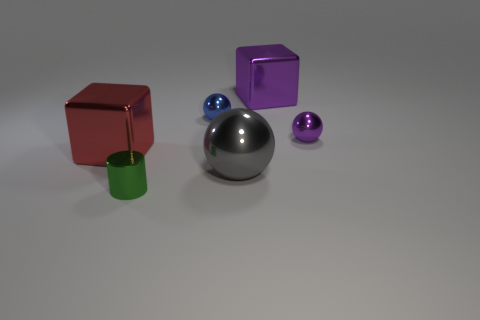There is a tiny cylinder in front of the cube that is right of the large object that is to the left of the small green metal thing; what is its material?
Offer a terse response. Metal. What number of red things are there?
Provide a short and direct response. 1. How many cyan objects are big balls or small balls?
Provide a short and direct response. 0. What number of other objects are the same shape as the large purple object?
Your answer should be compact. 1. There is a cube that is right of the small green metallic thing; does it have the same color as the tiny sphere that is in front of the blue sphere?
Make the answer very short. Yes. How many small things are either blue shiny balls or purple balls?
Your answer should be compact. 2. What is the size of the blue thing that is the same shape as the gray thing?
Your answer should be very brief. Small. What material is the purple object on the right side of the cube right of the big metal ball?
Your response must be concise. Metal. How many matte objects are either cylinders or small blue spheres?
Offer a very short reply. 0. The other large object that is the same shape as the large red shiny thing is what color?
Ensure brevity in your answer.  Purple. 